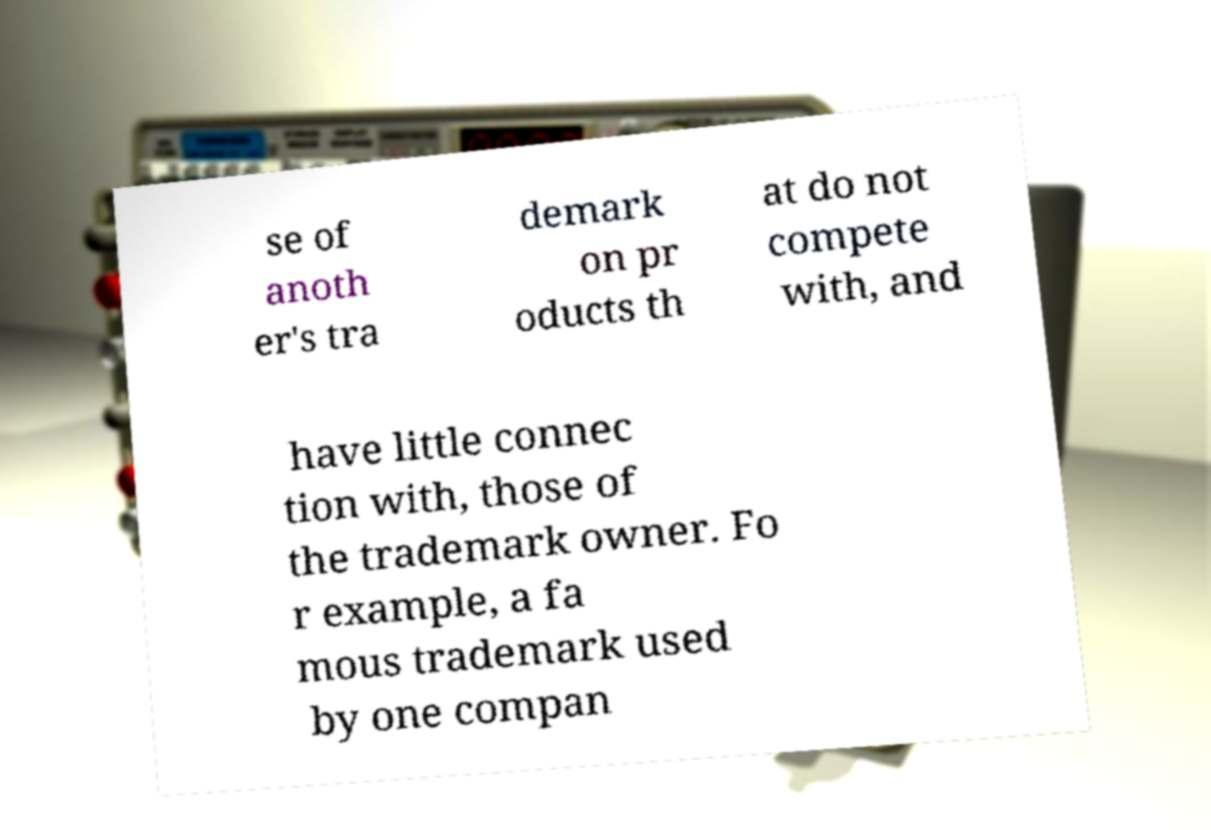Please read and relay the text visible in this image. What does it say? se of anoth er's tra demark on pr oducts th at do not compete with, and have little connec tion with, those of the trademark owner. Fo r example, a fa mous trademark used by one compan 